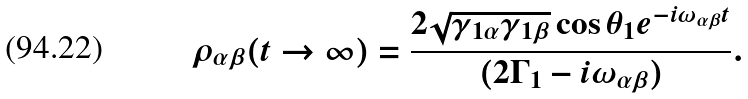Convert formula to latex. <formula><loc_0><loc_0><loc_500><loc_500>\rho _ { \alpha \beta } ( t \rightarrow \infty ) = \frac { 2 \sqrt { \gamma _ { 1 \alpha } \gamma _ { 1 \beta } } \cos \theta _ { 1 } e ^ { - i \omega _ { \alpha \beta } t } } { ( 2 \Gamma _ { 1 } - i \omega _ { \alpha \beta } ) } .</formula> 